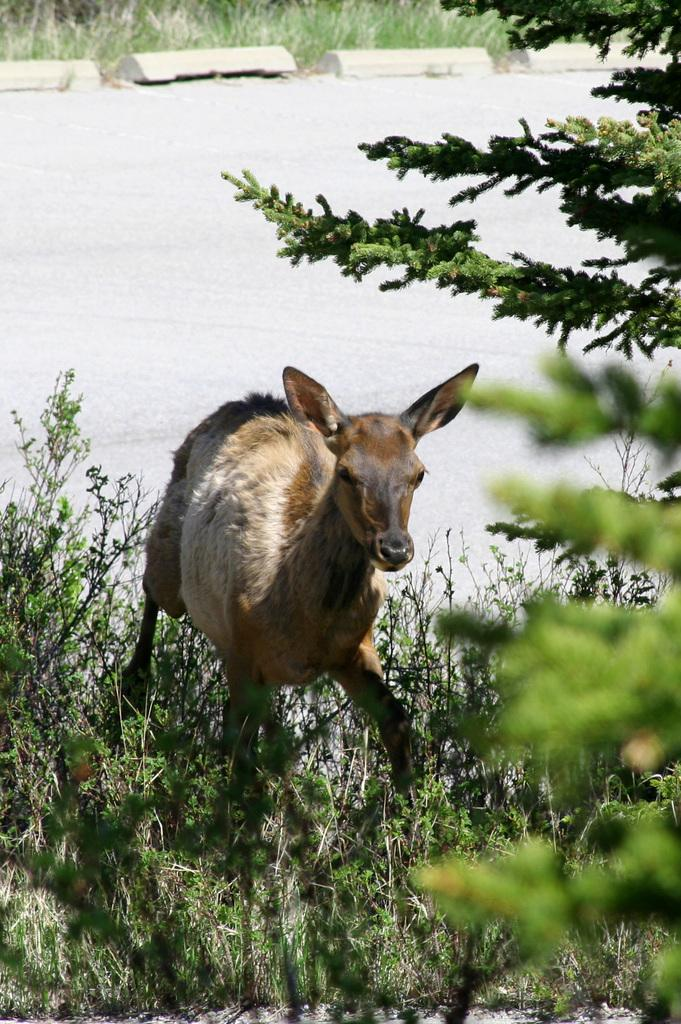What is the primary element in the image? There is water in the image. What type of vegetation can be seen in the image? There are plants and leaves visible in the image. What type of ground cover is visible in the background of the image? There is grass visible in the background of the image. What type of brick is used to build the rule in the image? There is no brick or rule present in the image. How are the plants sorted in the image? The plants are not sorted in the image; they are simply visible. 